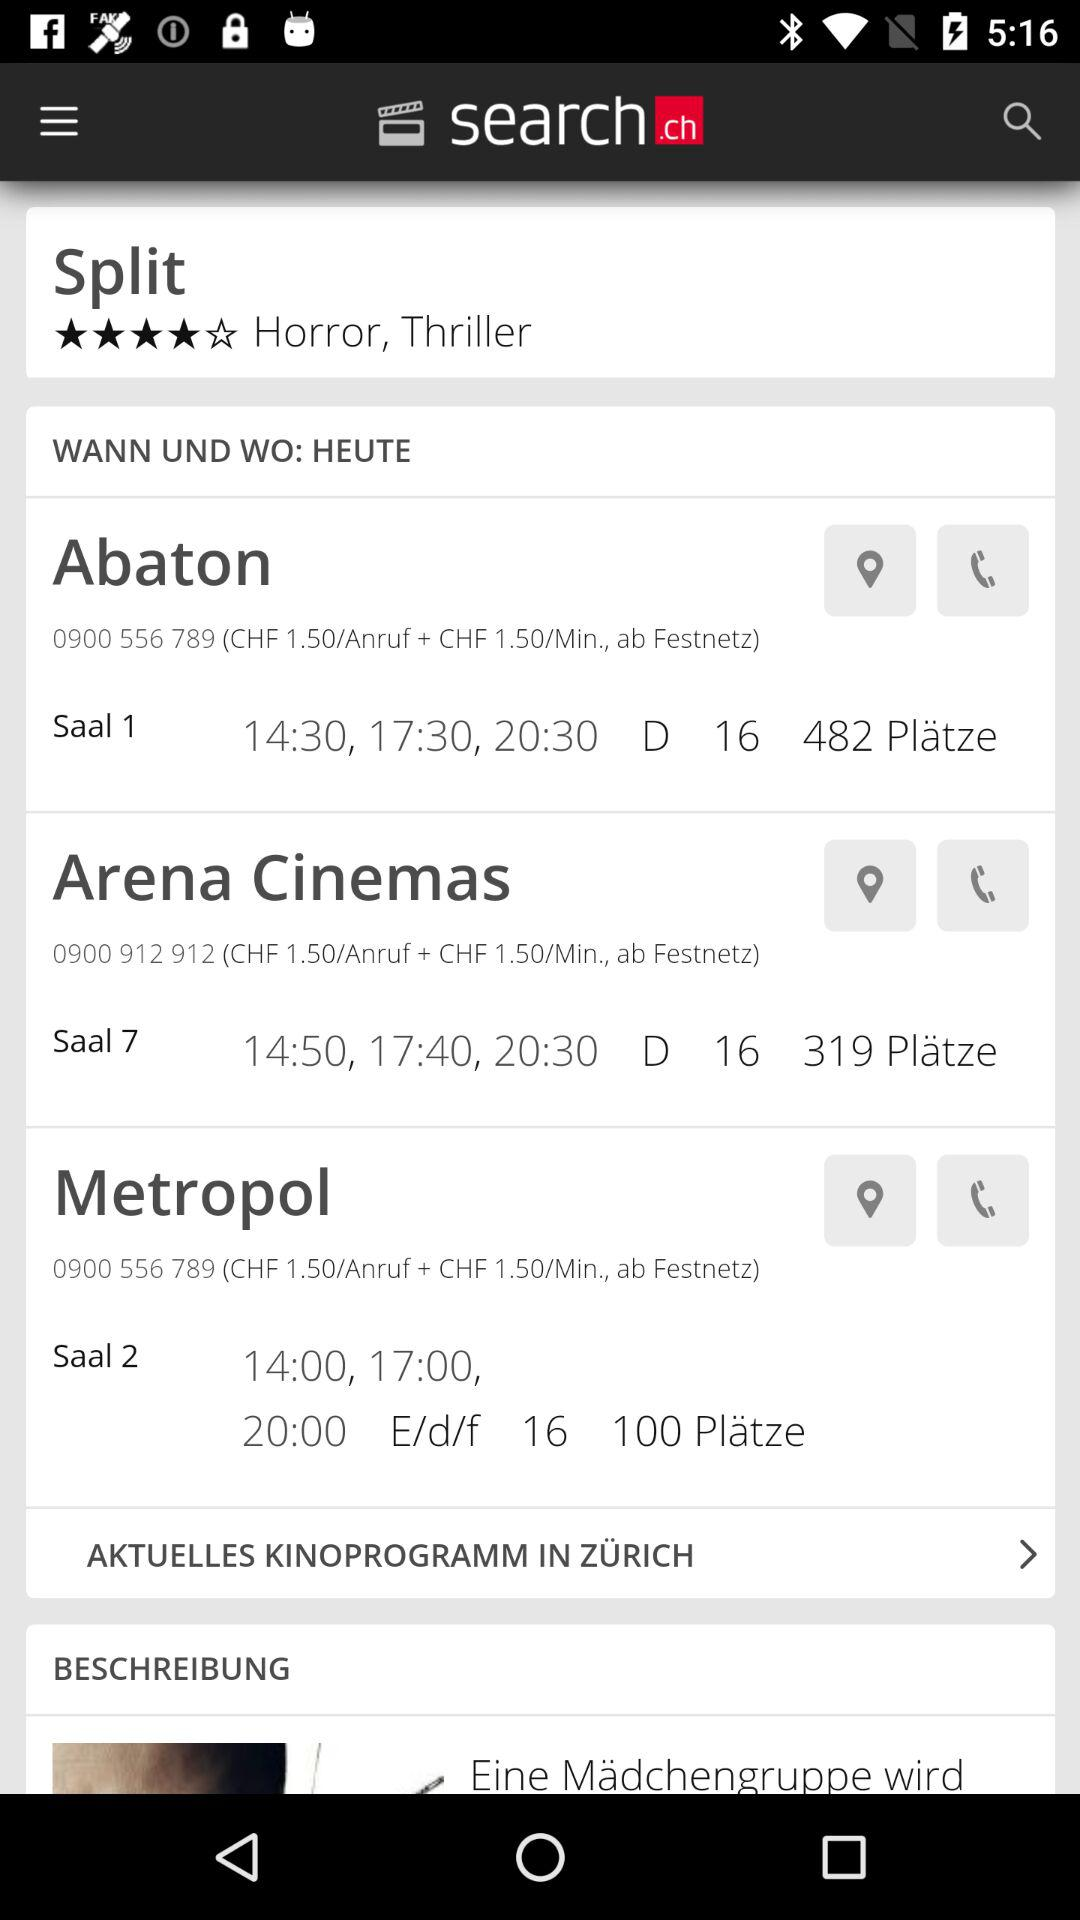How many more seats are there in Saal 1 than in Saal 2?
Answer the question using a single word or phrase. 382 